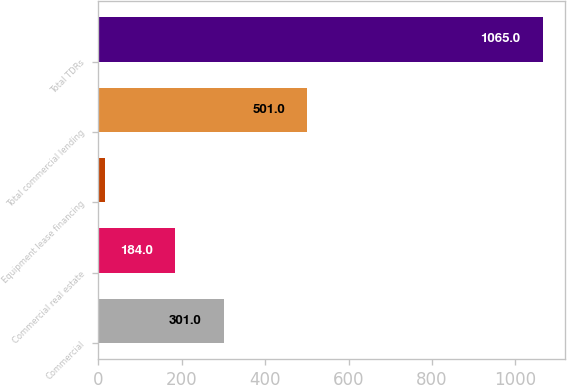<chart> <loc_0><loc_0><loc_500><loc_500><bar_chart><fcel>Commercial<fcel>Commercial real estate<fcel>Equipment lease financing<fcel>Total commercial lending<fcel>Total TDRs<nl><fcel>301<fcel>184<fcel>16<fcel>501<fcel>1065<nl></chart> 